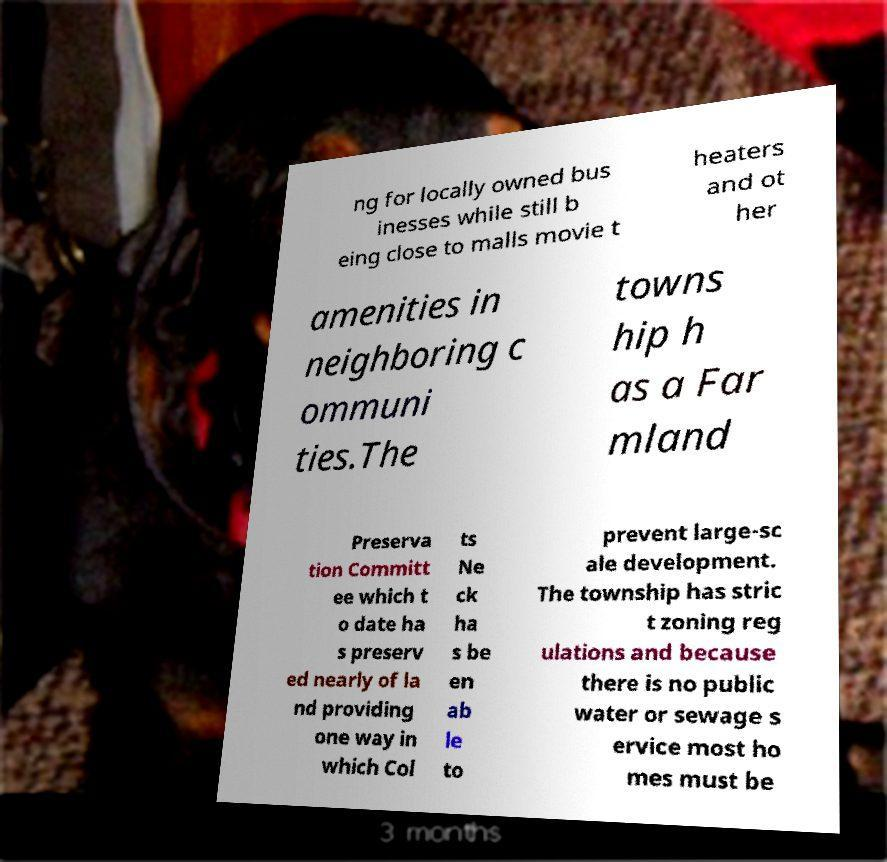Please identify and transcribe the text found in this image. ng for locally owned bus inesses while still b eing close to malls movie t heaters and ot her amenities in neighboring c ommuni ties.The towns hip h as a Far mland Preserva tion Committ ee which t o date ha s preserv ed nearly of la nd providing one way in which Col ts Ne ck ha s be en ab le to prevent large-sc ale development. The township has stric t zoning reg ulations and because there is no public water or sewage s ervice most ho mes must be 